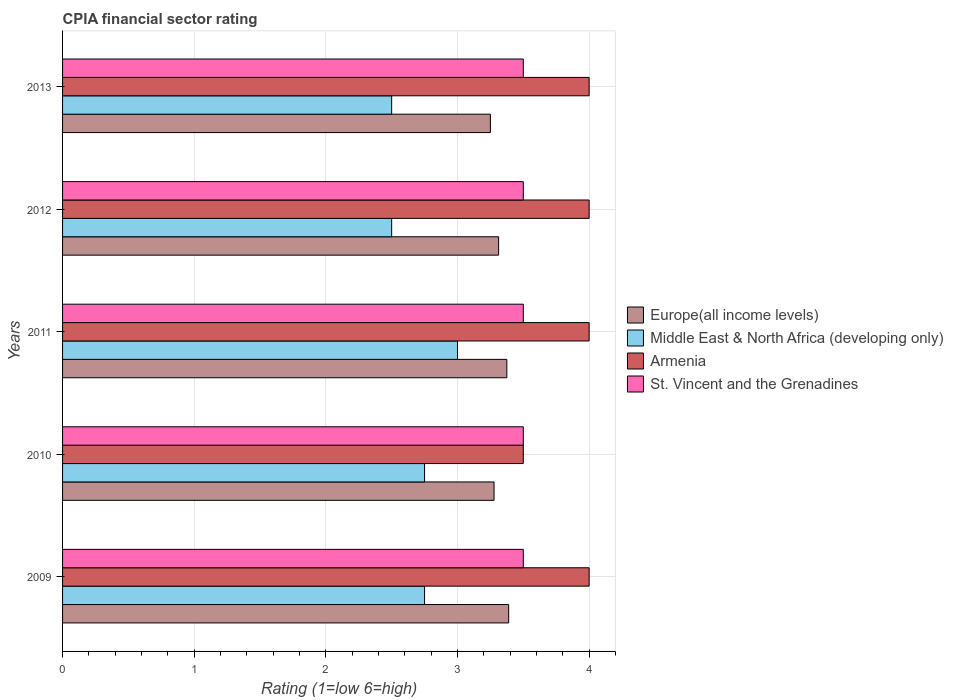How many groups of bars are there?
Your answer should be compact. 5. Are the number of bars per tick equal to the number of legend labels?
Make the answer very short. Yes. How many bars are there on the 2nd tick from the bottom?
Ensure brevity in your answer.  4. In how many cases, is the number of bars for a given year not equal to the number of legend labels?
Keep it short and to the point. 0. What is the CPIA rating in St. Vincent and the Grenadines in 2011?
Your response must be concise. 3.5. Across all years, what is the minimum CPIA rating in Middle East & North Africa (developing only)?
Your response must be concise. 2.5. In which year was the CPIA rating in Armenia minimum?
Your answer should be very brief. 2010. What is the difference between the CPIA rating in Armenia in 2011 and that in 2012?
Provide a succinct answer. 0. What is the difference between the CPIA rating in Europe(all income levels) in 2011 and the CPIA rating in Armenia in 2012?
Your answer should be very brief. -0.62. In the year 2009, what is the difference between the CPIA rating in Europe(all income levels) and CPIA rating in Armenia?
Your answer should be very brief. -0.61. In how many years, is the CPIA rating in Middle East & North Africa (developing only) greater than 1.4 ?
Your answer should be compact. 5. What is the ratio of the CPIA rating in Europe(all income levels) in 2010 to that in 2013?
Provide a short and direct response. 1.01. What is the difference between the highest and the second highest CPIA rating in Middle East & North Africa (developing only)?
Make the answer very short. 0.25. What is the difference between the highest and the lowest CPIA rating in Europe(all income levels)?
Offer a terse response. 0.14. In how many years, is the CPIA rating in Middle East & North Africa (developing only) greater than the average CPIA rating in Middle East & North Africa (developing only) taken over all years?
Keep it short and to the point. 3. Is it the case that in every year, the sum of the CPIA rating in Armenia and CPIA rating in Europe(all income levels) is greater than the sum of CPIA rating in St. Vincent and the Grenadines and CPIA rating in Middle East & North Africa (developing only)?
Make the answer very short. No. What does the 2nd bar from the top in 2009 represents?
Provide a short and direct response. Armenia. What does the 4th bar from the bottom in 2012 represents?
Offer a very short reply. St. Vincent and the Grenadines. How many years are there in the graph?
Offer a very short reply. 5. What is the difference between two consecutive major ticks on the X-axis?
Your answer should be compact. 1. Are the values on the major ticks of X-axis written in scientific E-notation?
Give a very brief answer. No. Does the graph contain any zero values?
Your answer should be very brief. No. Does the graph contain grids?
Offer a very short reply. Yes. Where does the legend appear in the graph?
Your response must be concise. Center right. How many legend labels are there?
Your response must be concise. 4. What is the title of the graph?
Provide a succinct answer. CPIA financial sector rating. What is the label or title of the X-axis?
Your answer should be very brief. Rating (1=low 6=high). What is the Rating (1=low 6=high) of Europe(all income levels) in 2009?
Your answer should be compact. 3.39. What is the Rating (1=low 6=high) in Middle East & North Africa (developing only) in 2009?
Provide a succinct answer. 2.75. What is the Rating (1=low 6=high) of Armenia in 2009?
Provide a short and direct response. 4. What is the Rating (1=low 6=high) of Europe(all income levels) in 2010?
Offer a terse response. 3.28. What is the Rating (1=low 6=high) in Middle East & North Africa (developing only) in 2010?
Your response must be concise. 2.75. What is the Rating (1=low 6=high) of St. Vincent and the Grenadines in 2010?
Make the answer very short. 3.5. What is the Rating (1=low 6=high) in Europe(all income levels) in 2011?
Provide a succinct answer. 3.38. What is the Rating (1=low 6=high) in Middle East & North Africa (developing only) in 2011?
Provide a short and direct response. 3. What is the Rating (1=low 6=high) of Armenia in 2011?
Offer a terse response. 4. What is the Rating (1=low 6=high) of St. Vincent and the Grenadines in 2011?
Offer a very short reply. 3.5. What is the Rating (1=low 6=high) of Europe(all income levels) in 2012?
Your answer should be compact. 3.31. What is the Rating (1=low 6=high) of Middle East & North Africa (developing only) in 2012?
Provide a short and direct response. 2.5. What is the Rating (1=low 6=high) of Armenia in 2012?
Provide a succinct answer. 4. What is the Rating (1=low 6=high) of Middle East & North Africa (developing only) in 2013?
Provide a succinct answer. 2.5. What is the Rating (1=low 6=high) of Armenia in 2013?
Keep it short and to the point. 4. Across all years, what is the maximum Rating (1=low 6=high) in Europe(all income levels)?
Keep it short and to the point. 3.39. Across all years, what is the maximum Rating (1=low 6=high) in Middle East & North Africa (developing only)?
Give a very brief answer. 3. Across all years, what is the maximum Rating (1=low 6=high) of St. Vincent and the Grenadines?
Offer a terse response. 3.5. Across all years, what is the minimum Rating (1=low 6=high) of Middle East & North Africa (developing only)?
Your answer should be very brief. 2.5. Across all years, what is the minimum Rating (1=low 6=high) of Armenia?
Offer a very short reply. 3.5. What is the total Rating (1=low 6=high) of Europe(all income levels) in the graph?
Offer a terse response. 16.6. What is the total Rating (1=low 6=high) of Middle East & North Africa (developing only) in the graph?
Your response must be concise. 13.5. What is the total Rating (1=low 6=high) of St. Vincent and the Grenadines in the graph?
Keep it short and to the point. 17.5. What is the difference between the Rating (1=low 6=high) of Europe(all income levels) in 2009 and that in 2010?
Offer a terse response. 0.11. What is the difference between the Rating (1=low 6=high) in Middle East & North Africa (developing only) in 2009 and that in 2010?
Offer a terse response. 0. What is the difference between the Rating (1=low 6=high) of St. Vincent and the Grenadines in 2009 and that in 2010?
Your answer should be very brief. 0. What is the difference between the Rating (1=low 6=high) of Europe(all income levels) in 2009 and that in 2011?
Offer a very short reply. 0.01. What is the difference between the Rating (1=low 6=high) of Middle East & North Africa (developing only) in 2009 and that in 2011?
Ensure brevity in your answer.  -0.25. What is the difference between the Rating (1=low 6=high) in Europe(all income levels) in 2009 and that in 2012?
Provide a short and direct response. 0.08. What is the difference between the Rating (1=low 6=high) in Middle East & North Africa (developing only) in 2009 and that in 2012?
Provide a short and direct response. 0.25. What is the difference between the Rating (1=low 6=high) in St. Vincent and the Grenadines in 2009 and that in 2012?
Offer a terse response. 0. What is the difference between the Rating (1=low 6=high) in Europe(all income levels) in 2009 and that in 2013?
Make the answer very short. 0.14. What is the difference between the Rating (1=low 6=high) of Armenia in 2009 and that in 2013?
Ensure brevity in your answer.  0. What is the difference between the Rating (1=low 6=high) of Europe(all income levels) in 2010 and that in 2011?
Your response must be concise. -0.1. What is the difference between the Rating (1=low 6=high) in Europe(all income levels) in 2010 and that in 2012?
Provide a succinct answer. -0.03. What is the difference between the Rating (1=low 6=high) in Europe(all income levels) in 2010 and that in 2013?
Your answer should be compact. 0.03. What is the difference between the Rating (1=low 6=high) of Middle East & North Africa (developing only) in 2010 and that in 2013?
Make the answer very short. 0.25. What is the difference between the Rating (1=low 6=high) in St. Vincent and the Grenadines in 2010 and that in 2013?
Give a very brief answer. 0. What is the difference between the Rating (1=low 6=high) of Europe(all income levels) in 2011 and that in 2012?
Provide a succinct answer. 0.06. What is the difference between the Rating (1=low 6=high) in Middle East & North Africa (developing only) in 2011 and that in 2012?
Your answer should be compact. 0.5. What is the difference between the Rating (1=low 6=high) of Armenia in 2011 and that in 2013?
Your response must be concise. 0. What is the difference between the Rating (1=low 6=high) in St. Vincent and the Grenadines in 2011 and that in 2013?
Offer a very short reply. 0. What is the difference between the Rating (1=low 6=high) of Europe(all income levels) in 2012 and that in 2013?
Your answer should be compact. 0.06. What is the difference between the Rating (1=low 6=high) of Europe(all income levels) in 2009 and the Rating (1=low 6=high) of Middle East & North Africa (developing only) in 2010?
Offer a terse response. 0.64. What is the difference between the Rating (1=low 6=high) of Europe(all income levels) in 2009 and the Rating (1=low 6=high) of Armenia in 2010?
Offer a very short reply. -0.11. What is the difference between the Rating (1=low 6=high) in Europe(all income levels) in 2009 and the Rating (1=low 6=high) in St. Vincent and the Grenadines in 2010?
Give a very brief answer. -0.11. What is the difference between the Rating (1=low 6=high) in Middle East & North Africa (developing only) in 2009 and the Rating (1=low 6=high) in Armenia in 2010?
Make the answer very short. -0.75. What is the difference between the Rating (1=low 6=high) in Middle East & North Africa (developing only) in 2009 and the Rating (1=low 6=high) in St. Vincent and the Grenadines in 2010?
Your answer should be compact. -0.75. What is the difference between the Rating (1=low 6=high) in Armenia in 2009 and the Rating (1=low 6=high) in St. Vincent and the Grenadines in 2010?
Ensure brevity in your answer.  0.5. What is the difference between the Rating (1=low 6=high) of Europe(all income levels) in 2009 and the Rating (1=low 6=high) of Middle East & North Africa (developing only) in 2011?
Offer a terse response. 0.39. What is the difference between the Rating (1=low 6=high) of Europe(all income levels) in 2009 and the Rating (1=low 6=high) of Armenia in 2011?
Keep it short and to the point. -0.61. What is the difference between the Rating (1=low 6=high) in Europe(all income levels) in 2009 and the Rating (1=low 6=high) in St. Vincent and the Grenadines in 2011?
Your answer should be very brief. -0.11. What is the difference between the Rating (1=low 6=high) in Middle East & North Africa (developing only) in 2009 and the Rating (1=low 6=high) in Armenia in 2011?
Your answer should be very brief. -1.25. What is the difference between the Rating (1=low 6=high) in Middle East & North Africa (developing only) in 2009 and the Rating (1=low 6=high) in St. Vincent and the Grenadines in 2011?
Provide a short and direct response. -0.75. What is the difference between the Rating (1=low 6=high) of Europe(all income levels) in 2009 and the Rating (1=low 6=high) of Armenia in 2012?
Your answer should be very brief. -0.61. What is the difference between the Rating (1=low 6=high) in Europe(all income levels) in 2009 and the Rating (1=low 6=high) in St. Vincent and the Grenadines in 2012?
Provide a succinct answer. -0.11. What is the difference between the Rating (1=low 6=high) in Middle East & North Africa (developing only) in 2009 and the Rating (1=low 6=high) in Armenia in 2012?
Your response must be concise. -1.25. What is the difference between the Rating (1=low 6=high) of Middle East & North Africa (developing only) in 2009 and the Rating (1=low 6=high) of St. Vincent and the Grenadines in 2012?
Provide a succinct answer. -0.75. What is the difference between the Rating (1=low 6=high) of Armenia in 2009 and the Rating (1=low 6=high) of St. Vincent and the Grenadines in 2012?
Keep it short and to the point. 0.5. What is the difference between the Rating (1=low 6=high) of Europe(all income levels) in 2009 and the Rating (1=low 6=high) of Middle East & North Africa (developing only) in 2013?
Your response must be concise. 0.89. What is the difference between the Rating (1=low 6=high) of Europe(all income levels) in 2009 and the Rating (1=low 6=high) of Armenia in 2013?
Provide a short and direct response. -0.61. What is the difference between the Rating (1=low 6=high) of Europe(all income levels) in 2009 and the Rating (1=low 6=high) of St. Vincent and the Grenadines in 2013?
Your answer should be very brief. -0.11. What is the difference between the Rating (1=low 6=high) in Middle East & North Africa (developing only) in 2009 and the Rating (1=low 6=high) in Armenia in 2013?
Your answer should be compact. -1.25. What is the difference between the Rating (1=low 6=high) of Middle East & North Africa (developing only) in 2009 and the Rating (1=low 6=high) of St. Vincent and the Grenadines in 2013?
Make the answer very short. -0.75. What is the difference between the Rating (1=low 6=high) in Armenia in 2009 and the Rating (1=low 6=high) in St. Vincent and the Grenadines in 2013?
Ensure brevity in your answer.  0.5. What is the difference between the Rating (1=low 6=high) of Europe(all income levels) in 2010 and the Rating (1=low 6=high) of Middle East & North Africa (developing only) in 2011?
Keep it short and to the point. 0.28. What is the difference between the Rating (1=low 6=high) in Europe(all income levels) in 2010 and the Rating (1=low 6=high) in Armenia in 2011?
Give a very brief answer. -0.72. What is the difference between the Rating (1=low 6=high) in Europe(all income levels) in 2010 and the Rating (1=low 6=high) in St. Vincent and the Grenadines in 2011?
Your answer should be very brief. -0.22. What is the difference between the Rating (1=low 6=high) in Middle East & North Africa (developing only) in 2010 and the Rating (1=low 6=high) in Armenia in 2011?
Your response must be concise. -1.25. What is the difference between the Rating (1=low 6=high) in Middle East & North Africa (developing only) in 2010 and the Rating (1=low 6=high) in St. Vincent and the Grenadines in 2011?
Your answer should be very brief. -0.75. What is the difference between the Rating (1=low 6=high) in Armenia in 2010 and the Rating (1=low 6=high) in St. Vincent and the Grenadines in 2011?
Offer a terse response. 0. What is the difference between the Rating (1=low 6=high) of Europe(all income levels) in 2010 and the Rating (1=low 6=high) of Middle East & North Africa (developing only) in 2012?
Keep it short and to the point. 0.78. What is the difference between the Rating (1=low 6=high) in Europe(all income levels) in 2010 and the Rating (1=low 6=high) in Armenia in 2012?
Your response must be concise. -0.72. What is the difference between the Rating (1=low 6=high) in Europe(all income levels) in 2010 and the Rating (1=low 6=high) in St. Vincent and the Grenadines in 2012?
Offer a terse response. -0.22. What is the difference between the Rating (1=low 6=high) of Middle East & North Africa (developing only) in 2010 and the Rating (1=low 6=high) of Armenia in 2012?
Your answer should be compact. -1.25. What is the difference between the Rating (1=low 6=high) of Middle East & North Africa (developing only) in 2010 and the Rating (1=low 6=high) of St. Vincent and the Grenadines in 2012?
Ensure brevity in your answer.  -0.75. What is the difference between the Rating (1=low 6=high) in Armenia in 2010 and the Rating (1=low 6=high) in St. Vincent and the Grenadines in 2012?
Ensure brevity in your answer.  0. What is the difference between the Rating (1=low 6=high) in Europe(all income levels) in 2010 and the Rating (1=low 6=high) in Middle East & North Africa (developing only) in 2013?
Your answer should be compact. 0.78. What is the difference between the Rating (1=low 6=high) of Europe(all income levels) in 2010 and the Rating (1=low 6=high) of Armenia in 2013?
Keep it short and to the point. -0.72. What is the difference between the Rating (1=low 6=high) of Europe(all income levels) in 2010 and the Rating (1=low 6=high) of St. Vincent and the Grenadines in 2013?
Your answer should be very brief. -0.22. What is the difference between the Rating (1=low 6=high) in Middle East & North Africa (developing only) in 2010 and the Rating (1=low 6=high) in Armenia in 2013?
Offer a terse response. -1.25. What is the difference between the Rating (1=low 6=high) in Middle East & North Africa (developing only) in 2010 and the Rating (1=low 6=high) in St. Vincent and the Grenadines in 2013?
Offer a very short reply. -0.75. What is the difference between the Rating (1=low 6=high) in Armenia in 2010 and the Rating (1=low 6=high) in St. Vincent and the Grenadines in 2013?
Your answer should be compact. 0. What is the difference between the Rating (1=low 6=high) of Europe(all income levels) in 2011 and the Rating (1=low 6=high) of Armenia in 2012?
Provide a succinct answer. -0.62. What is the difference between the Rating (1=low 6=high) in Europe(all income levels) in 2011 and the Rating (1=low 6=high) in St. Vincent and the Grenadines in 2012?
Your answer should be very brief. -0.12. What is the difference between the Rating (1=low 6=high) in Middle East & North Africa (developing only) in 2011 and the Rating (1=low 6=high) in Armenia in 2012?
Provide a short and direct response. -1. What is the difference between the Rating (1=low 6=high) in Middle East & North Africa (developing only) in 2011 and the Rating (1=low 6=high) in St. Vincent and the Grenadines in 2012?
Make the answer very short. -0.5. What is the difference between the Rating (1=low 6=high) of Armenia in 2011 and the Rating (1=low 6=high) of St. Vincent and the Grenadines in 2012?
Provide a succinct answer. 0.5. What is the difference between the Rating (1=low 6=high) in Europe(all income levels) in 2011 and the Rating (1=low 6=high) in Armenia in 2013?
Your answer should be very brief. -0.62. What is the difference between the Rating (1=low 6=high) of Europe(all income levels) in 2011 and the Rating (1=low 6=high) of St. Vincent and the Grenadines in 2013?
Offer a terse response. -0.12. What is the difference between the Rating (1=low 6=high) of Middle East & North Africa (developing only) in 2011 and the Rating (1=low 6=high) of Armenia in 2013?
Give a very brief answer. -1. What is the difference between the Rating (1=low 6=high) in Europe(all income levels) in 2012 and the Rating (1=low 6=high) in Middle East & North Africa (developing only) in 2013?
Provide a succinct answer. 0.81. What is the difference between the Rating (1=low 6=high) of Europe(all income levels) in 2012 and the Rating (1=low 6=high) of Armenia in 2013?
Offer a very short reply. -0.69. What is the difference between the Rating (1=low 6=high) of Europe(all income levels) in 2012 and the Rating (1=low 6=high) of St. Vincent and the Grenadines in 2013?
Give a very brief answer. -0.19. What is the difference between the Rating (1=low 6=high) of Middle East & North Africa (developing only) in 2012 and the Rating (1=low 6=high) of Armenia in 2013?
Provide a succinct answer. -1.5. What is the difference between the Rating (1=low 6=high) in Armenia in 2012 and the Rating (1=low 6=high) in St. Vincent and the Grenadines in 2013?
Keep it short and to the point. 0.5. What is the average Rating (1=low 6=high) of Europe(all income levels) per year?
Offer a very short reply. 3.32. What is the average Rating (1=low 6=high) in St. Vincent and the Grenadines per year?
Your answer should be compact. 3.5. In the year 2009, what is the difference between the Rating (1=low 6=high) of Europe(all income levels) and Rating (1=low 6=high) of Middle East & North Africa (developing only)?
Make the answer very short. 0.64. In the year 2009, what is the difference between the Rating (1=low 6=high) in Europe(all income levels) and Rating (1=low 6=high) in Armenia?
Provide a short and direct response. -0.61. In the year 2009, what is the difference between the Rating (1=low 6=high) of Europe(all income levels) and Rating (1=low 6=high) of St. Vincent and the Grenadines?
Ensure brevity in your answer.  -0.11. In the year 2009, what is the difference between the Rating (1=low 6=high) in Middle East & North Africa (developing only) and Rating (1=low 6=high) in Armenia?
Offer a very short reply. -1.25. In the year 2009, what is the difference between the Rating (1=low 6=high) of Middle East & North Africa (developing only) and Rating (1=low 6=high) of St. Vincent and the Grenadines?
Your answer should be compact. -0.75. In the year 2009, what is the difference between the Rating (1=low 6=high) in Armenia and Rating (1=low 6=high) in St. Vincent and the Grenadines?
Your answer should be very brief. 0.5. In the year 2010, what is the difference between the Rating (1=low 6=high) in Europe(all income levels) and Rating (1=low 6=high) in Middle East & North Africa (developing only)?
Ensure brevity in your answer.  0.53. In the year 2010, what is the difference between the Rating (1=low 6=high) of Europe(all income levels) and Rating (1=low 6=high) of Armenia?
Your answer should be compact. -0.22. In the year 2010, what is the difference between the Rating (1=low 6=high) of Europe(all income levels) and Rating (1=low 6=high) of St. Vincent and the Grenadines?
Your response must be concise. -0.22. In the year 2010, what is the difference between the Rating (1=low 6=high) of Middle East & North Africa (developing only) and Rating (1=low 6=high) of Armenia?
Keep it short and to the point. -0.75. In the year 2010, what is the difference between the Rating (1=low 6=high) in Middle East & North Africa (developing only) and Rating (1=low 6=high) in St. Vincent and the Grenadines?
Offer a very short reply. -0.75. In the year 2010, what is the difference between the Rating (1=low 6=high) of Armenia and Rating (1=low 6=high) of St. Vincent and the Grenadines?
Provide a short and direct response. 0. In the year 2011, what is the difference between the Rating (1=low 6=high) in Europe(all income levels) and Rating (1=low 6=high) in Armenia?
Provide a short and direct response. -0.62. In the year 2011, what is the difference between the Rating (1=low 6=high) of Europe(all income levels) and Rating (1=low 6=high) of St. Vincent and the Grenadines?
Your answer should be very brief. -0.12. In the year 2011, what is the difference between the Rating (1=low 6=high) of Middle East & North Africa (developing only) and Rating (1=low 6=high) of Armenia?
Your answer should be compact. -1. In the year 2012, what is the difference between the Rating (1=low 6=high) in Europe(all income levels) and Rating (1=low 6=high) in Middle East & North Africa (developing only)?
Your answer should be very brief. 0.81. In the year 2012, what is the difference between the Rating (1=low 6=high) in Europe(all income levels) and Rating (1=low 6=high) in Armenia?
Offer a very short reply. -0.69. In the year 2012, what is the difference between the Rating (1=low 6=high) of Europe(all income levels) and Rating (1=low 6=high) of St. Vincent and the Grenadines?
Provide a short and direct response. -0.19. In the year 2012, what is the difference between the Rating (1=low 6=high) in Middle East & North Africa (developing only) and Rating (1=low 6=high) in Armenia?
Your response must be concise. -1.5. In the year 2012, what is the difference between the Rating (1=low 6=high) in Middle East & North Africa (developing only) and Rating (1=low 6=high) in St. Vincent and the Grenadines?
Give a very brief answer. -1. In the year 2012, what is the difference between the Rating (1=low 6=high) in Armenia and Rating (1=low 6=high) in St. Vincent and the Grenadines?
Make the answer very short. 0.5. In the year 2013, what is the difference between the Rating (1=low 6=high) of Europe(all income levels) and Rating (1=low 6=high) of Middle East & North Africa (developing only)?
Your response must be concise. 0.75. In the year 2013, what is the difference between the Rating (1=low 6=high) in Europe(all income levels) and Rating (1=low 6=high) in Armenia?
Offer a very short reply. -0.75. What is the ratio of the Rating (1=low 6=high) in Europe(all income levels) in 2009 to that in 2010?
Offer a very short reply. 1.03. What is the ratio of the Rating (1=low 6=high) in Middle East & North Africa (developing only) in 2009 to that in 2010?
Provide a succinct answer. 1. What is the ratio of the Rating (1=low 6=high) in Middle East & North Africa (developing only) in 2009 to that in 2011?
Keep it short and to the point. 0.92. What is the ratio of the Rating (1=low 6=high) in Armenia in 2009 to that in 2011?
Give a very brief answer. 1. What is the ratio of the Rating (1=low 6=high) in Europe(all income levels) in 2009 to that in 2012?
Keep it short and to the point. 1.02. What is the ratio of the Rating (1=low 6=high) in Armenia in 2009 to that in 2012?
Provide a succinct answer. 1. What is the ratio of the Rating (1=low 6=high) in St. Vincent and the Grenadines in 2009 to that in 2012?
Give a very brief answer. 1. What is the ratio of the Rating (1=low 6=high) of Europe(all income levels) in 2009 to that in 2013?
Offer a very short reply. 1.04. What is the ratio of the Rating (1=low 6=high) of Middle East & North Africa (developing only) in 2009 to that in 2013?
Your answer should be very brief. 1.1. What is the ratio of the Rating (1=low 6=high) of Armenia in 2009 to that in 2013?
Your answer should be compact. 1. What is the ratio of the Rating (1=low 6=high) of St. Vincent and the Grenadines in 2009 to that in 2013?
Your response must be concise. 1. What is the ratio of the Rating (1=low 6=high) in Europe(all income levels) in 2010 to that in 2011?
Keep it short and to the point. 0.97. What is the ratio of the Rating (1=low 6=high) of Middle East & North Africa (developing only) in 2010 to that in 2011?
Offer a very short reply. 0.92. What is the ratio of the Rating (1=low 6=high) in Armenia in 2010 to that in 2011?
Ensure brevity in your answer.  0.88. What is the ratio of the Rating (1=low 6=high) of St. Vincent and the Grenadines in 2010 to that in 2011?
Give a very brief answer. 1. What is the ratio of the Rating (1=low 6=high) of Europe(all income levels) in 2010 to that in 2012?
Give a very brief answer. 0.99. What is the ratio of the Rating (1=low 6=high) of Middle East & North Africa (developing only) in 2010 to that in 2012?
Make the answer very short. 1.1. What is the ratio of the Rating (1=low 6=high) in Armenia in 2010 to that in 2012?
Offer a very short reply. 0.88. What is the ratio of the Rating (1=low 6=high) in Europe(all income levels) in 2010 to that in 2013?
Your response must be concise. 1.01. What is the ratio of the Rating (1=low 6=high) in Europe(all income levels) in 2011 to that in 2012?
Your answer should be compact. 1.02. What is the ratio of the Rating (1=low 6=high) in Armenia in 2011 to that in 2012?
Your response must be concise. 1. What is the ratio of the Rating (1=low 6=high) in Europe(all income levels) in 2011 to that in 2013?
Provide a short and direct response. 1.04. What is the ratio of the Rating (1=low 6=high) of Middle East & North Africa (developing only) in 2011 to that in 2013?
Offer a very short reply. 1.2. What is the ratio of the Rating (1=low 6=high) in Armenia in 2011 to that in 2013?
Give a very brief answer. 1. What is the ratio of the Rating (1=low 6=high) of St. Vincent and the Grenadines in 2011 to that in 2013?
Make the answer very short. 1. What is the ratio of the Rating (1=low 6=high) in Europe(all income levels) in 2012 to that in 2013?
Keep it short and to the point. 1.02. What is the ratio of the Rating (1=low 6=high) of St. Vincent and the Grenadines in 2012 to that in 2013?
Provide a succinct answer. 1. What is the difference between the highest and the second highest Rating (1=low 6=high) in Europe(all income levels)?
Keep it short and to the point. 0.01. What is the difference between the highest and the second highest Rating (1=low 6=high) in Middle East & North Africa (developing only)?
Ensure brevity in your answer.  0.25. What is the difference between the highest and the second highest Rating (1=low 6=high) in St. Vincent and the Grenadines?
Offer a terse response. 0. What is the difference between the highest and the lowest Rating (1=low 6=high) of Europe(all income levels)?
Offer a terse response. 0.14. What is the difference between the highest and the lowest Rating (1=low 6=high) of Middle East & North Africa (developing only)?
Your answer should be very brief. 0.5. 